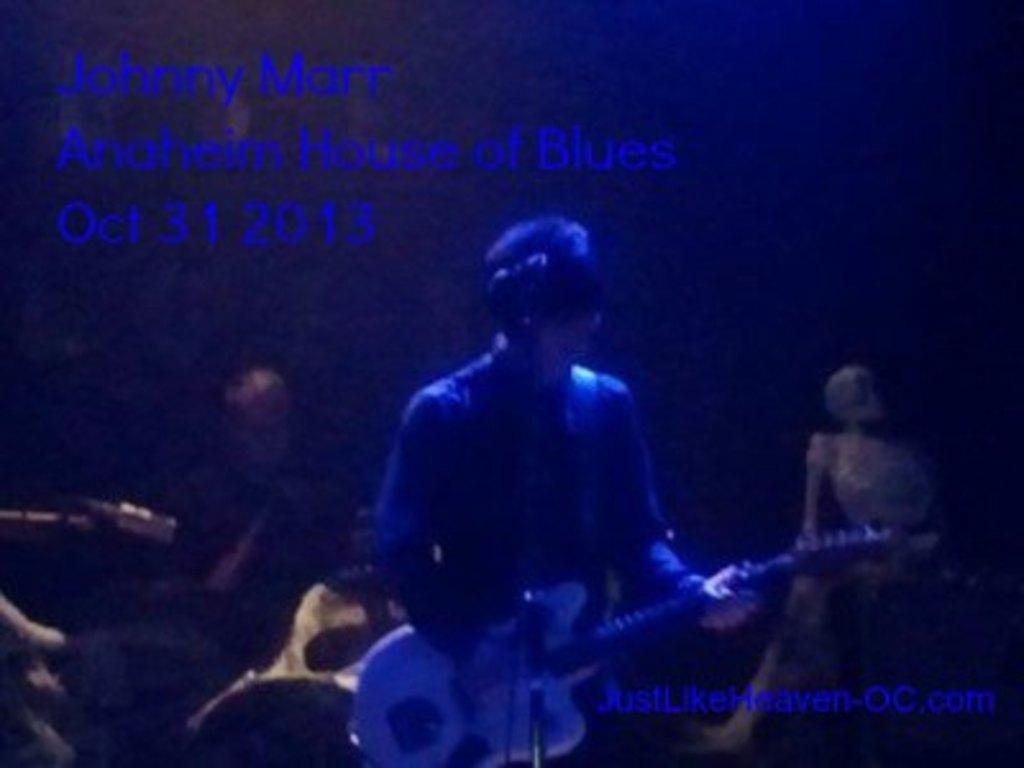What are the people in the image doing? The people in the image are playing musical instruments. Can you describe any text visible in the image? Yes, there is text in the top left corner and the bottom right corner of the image. What can be seen in the background of the image? There is a skeleton in the background of the image. How many beds are visible in the image? There are no beds present in the image. What language is the text written in the image? The provided facts do not mention the language of the text in the image. 